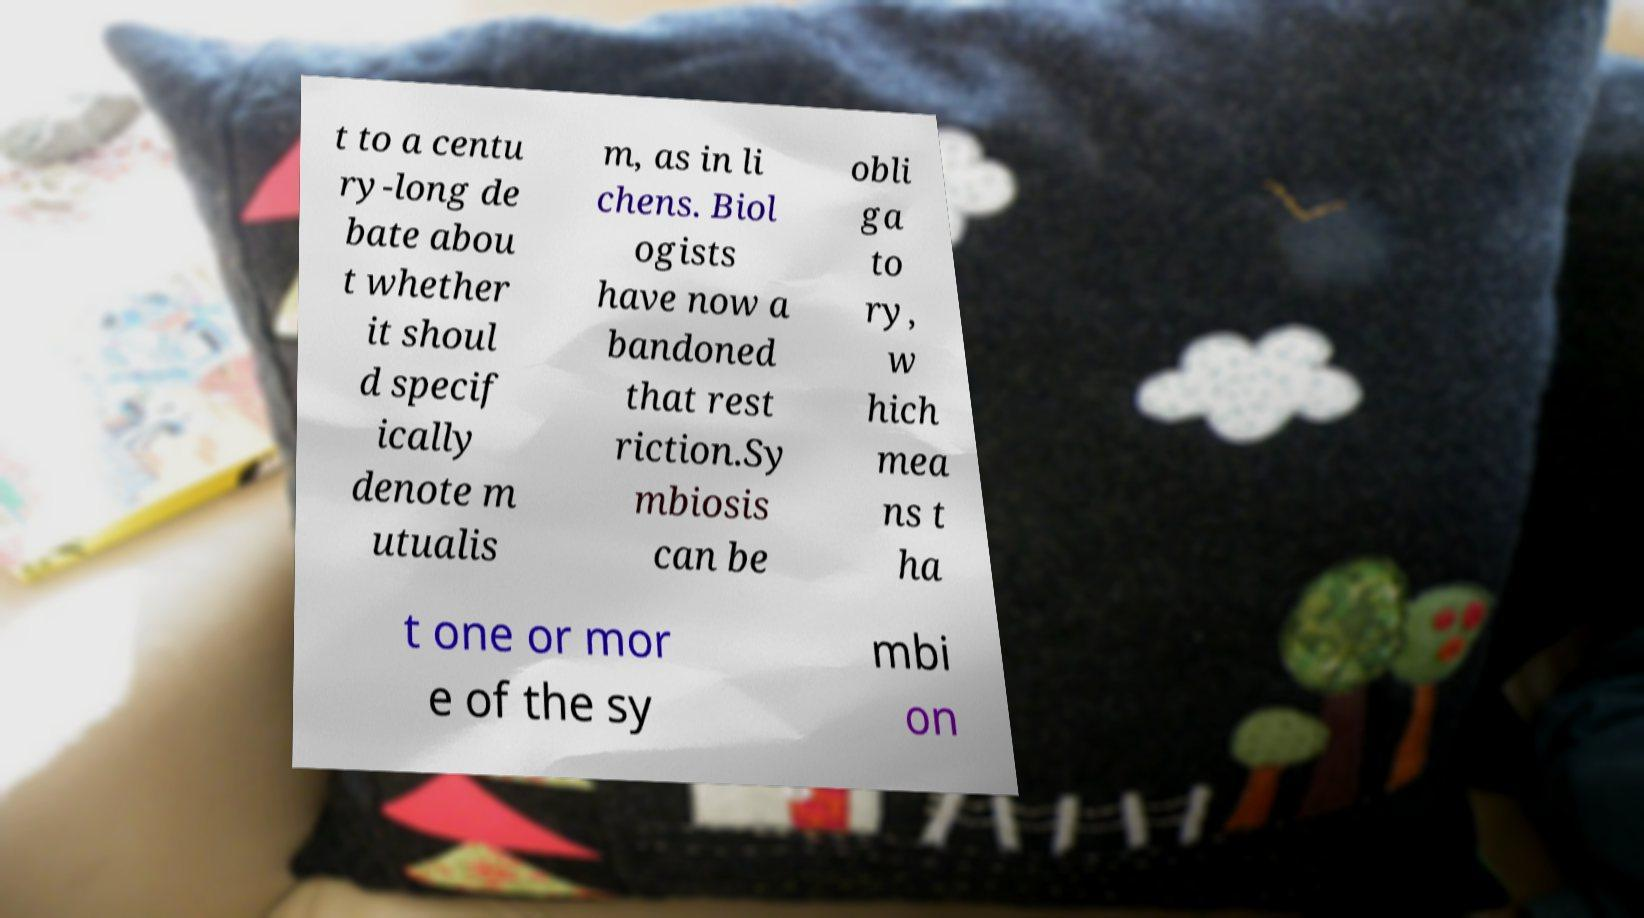Please identify and transcribe the text found in this image. t to a centu ry-long de bate abou t whether it shoul d specif ically denote m utualis m, as in li chens. Biol ogists have now a bandoned that rest riction.Sy mbiosis can be obli ga to ry, w hich mea ns t ha t one or mor e of the sy mbi on 